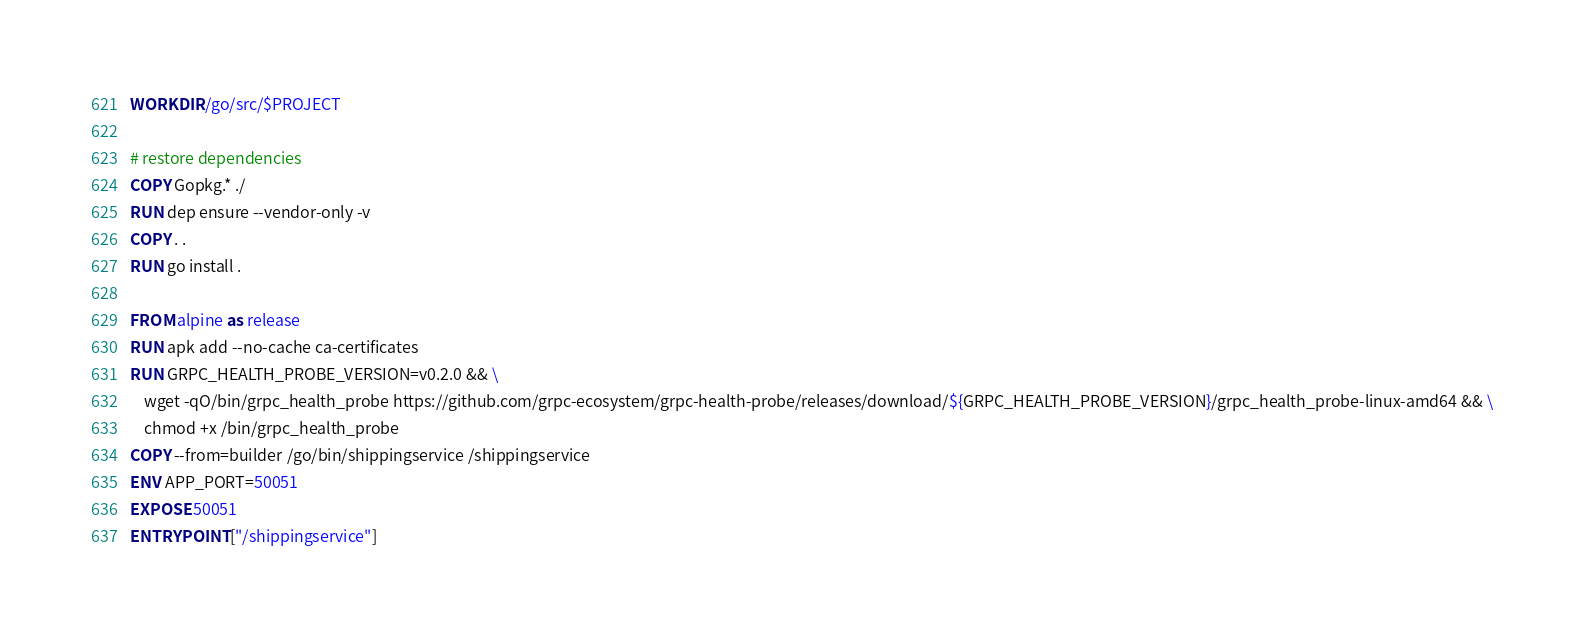Convert code to text. <code><loc_0><loc_0><loc_500><loc_500><_Dockerfile_>WORKDIR /go/src/$PROJECT

# restore dependencies
COPY Gopkg.* ./
RUN dep ensure --vendor-only -v
COPY . .
RUN go install .

FROM alpine as release
RUN apk add --no-cache ca-certificates
RUN GRPC_HEALTH_PROBE_VERSION=v0.2.0 && \
    wget -qO/bin/grpc_health_probe https://github.com/grpc-ecosystem/grpc-health-probe/releases/download/${GRPC_HEALTH_PROBE_VERSION}/grpc_health_probe-linux-amd64 && \
    chmod +x /bin/grpc_health_probe
COPY --from=builder /go/bin/shippingservice /shippingservice
ENV APP_PORT=50051
EXPOSE 50051
ENTRYPOINT ["/shippingservice"]
</code> 